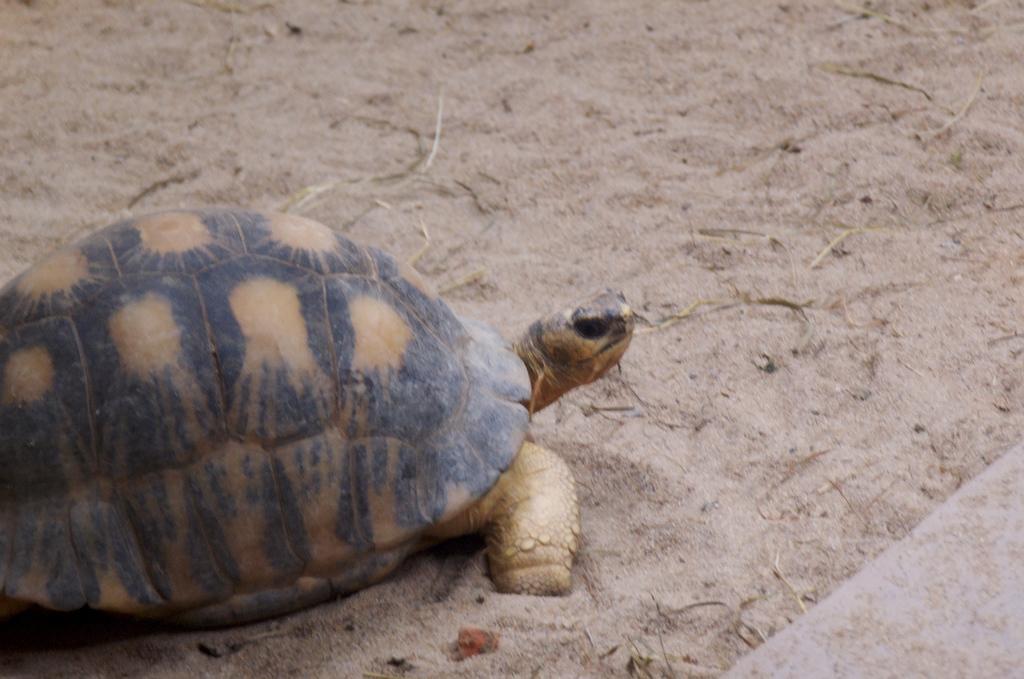Can you describe this image briefly? This pictures seems to be clicked outside. On the left we can see the tortoise seems to be walking on the ground. In the background we can see the sand on the ground. 